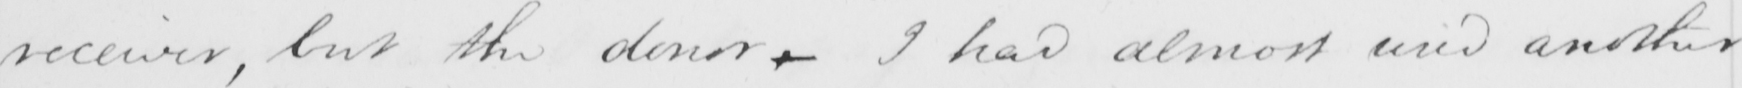What is written in this line of handwriting? receiver , but the donor- I had almost used another 